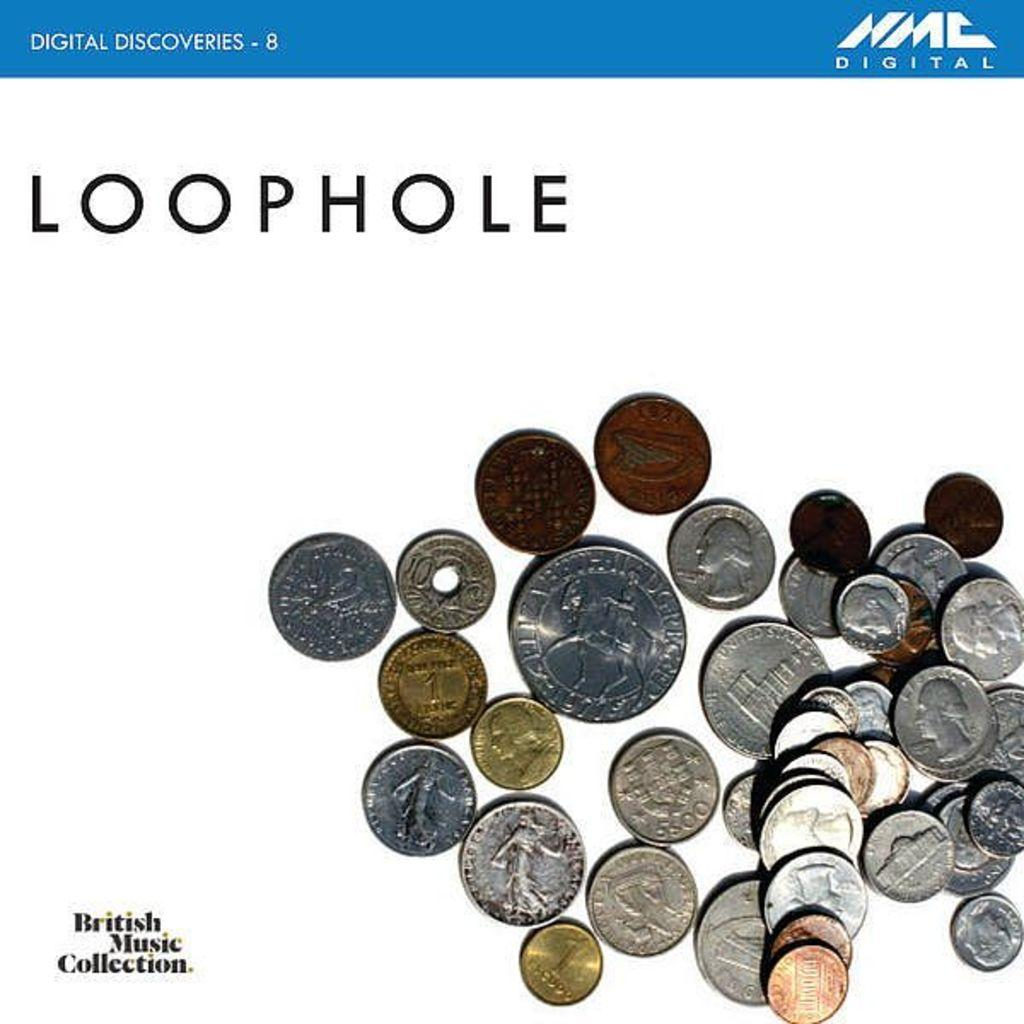Provide a one-sentence caption for the provided image. LOOPHOLE in capital letters is above a pile of coins from assorted countries. 